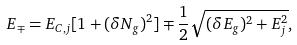<formula> <loc_0><loc_0><loc_500><loc_500>E _ { \mp } = E _ { C , j } [ 1 + ( \delta N _ { g } ) ^ { 2 } ] \mp \frac { 1 } { 2 } \sqrt { ( \delta E _ { g } ) ^ { 2 } + E _ { j } ^ { 2 } } ,</formula> 